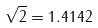<formula> <loc_0><loc_0><loc_500><loc_500>\sqrt { 2 } = 1 . 4 1 4 2</formula> 